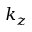<formula> <loc_0><loc_0><loc_500><loc_500>k _ { z }</formula> 